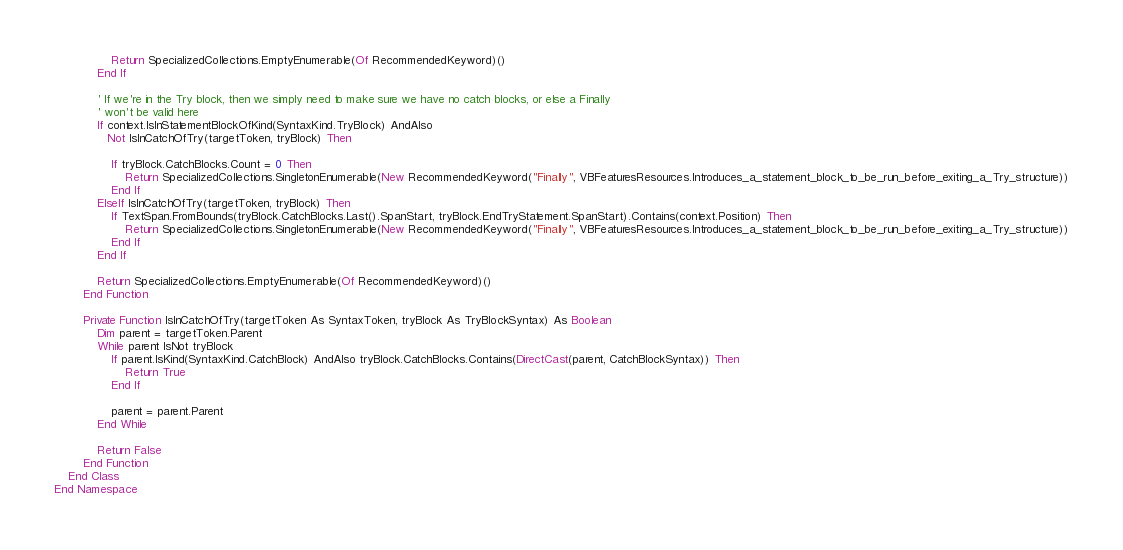Convert code to text. <code><loc_0><loc_0><loc_500><loc_500><_VisualBasic_>                Return SpecializedCollections.EmptyEnumerable(Of RecommendedKeyword)()
            End If

            ' If we're in the Try block, then we simply need to make sure we have no catch blocks, or else a Finally
            ' won't be valid here
            If context.IsInStatementBlockOfKind(SyntaxKind.TryBlock) AndAlso
               Not IsInCatchOfTry(targetToken, tryBlock) Then

                If tryBlock.CatchBlocks.Count = 0 Then
                    Return SpecializedCollections.SingletonEnumerable(New RecommendedKeyword("Finally", VBFeaturesResources.Introduces_a_statement_block_to_be_run_before_exiting_a_Try_structure))
                End If
            ElseIf IsInCatchOfTry(targetToken, tryBlock) Then
                If TextSpan.FromBounds(tryBlock.CatchBlocks.Last().SpanStart, tryBlock.EndTryStatement.SpanStart).Contains(context.Position) Then
                    Return SpecializedCollections.SingletonEnumerable(New RecommendedKeyword("Finally", VBFeaturesResources.Introduces_a_statement_block_to_be_run_before_exiting_a_Try_structure))
                End If
            End If

            Return SpecializedCollections.EmptyEnumerable(Of RecommendedKeyword)()
        End Function

        Private Function IsInCatchOfTry(targetToken As SyntaxToken, tryBlock As TryBlockSyntax) As Boolean
            Dim parent = targetToken.Parent
            While parent IsNot tryBlock
                If parent.IsKind(SyntaxKind.CatchBlock) AndAlso tryBlock.CatchBlocks.Contains(DirectCast(parent, CatchBlockSyntax)) Then
                    Return True
                End If

                parent = parent.Parent
            End While

            Return False
        End Function
    End Class
End Namespace
</code> 